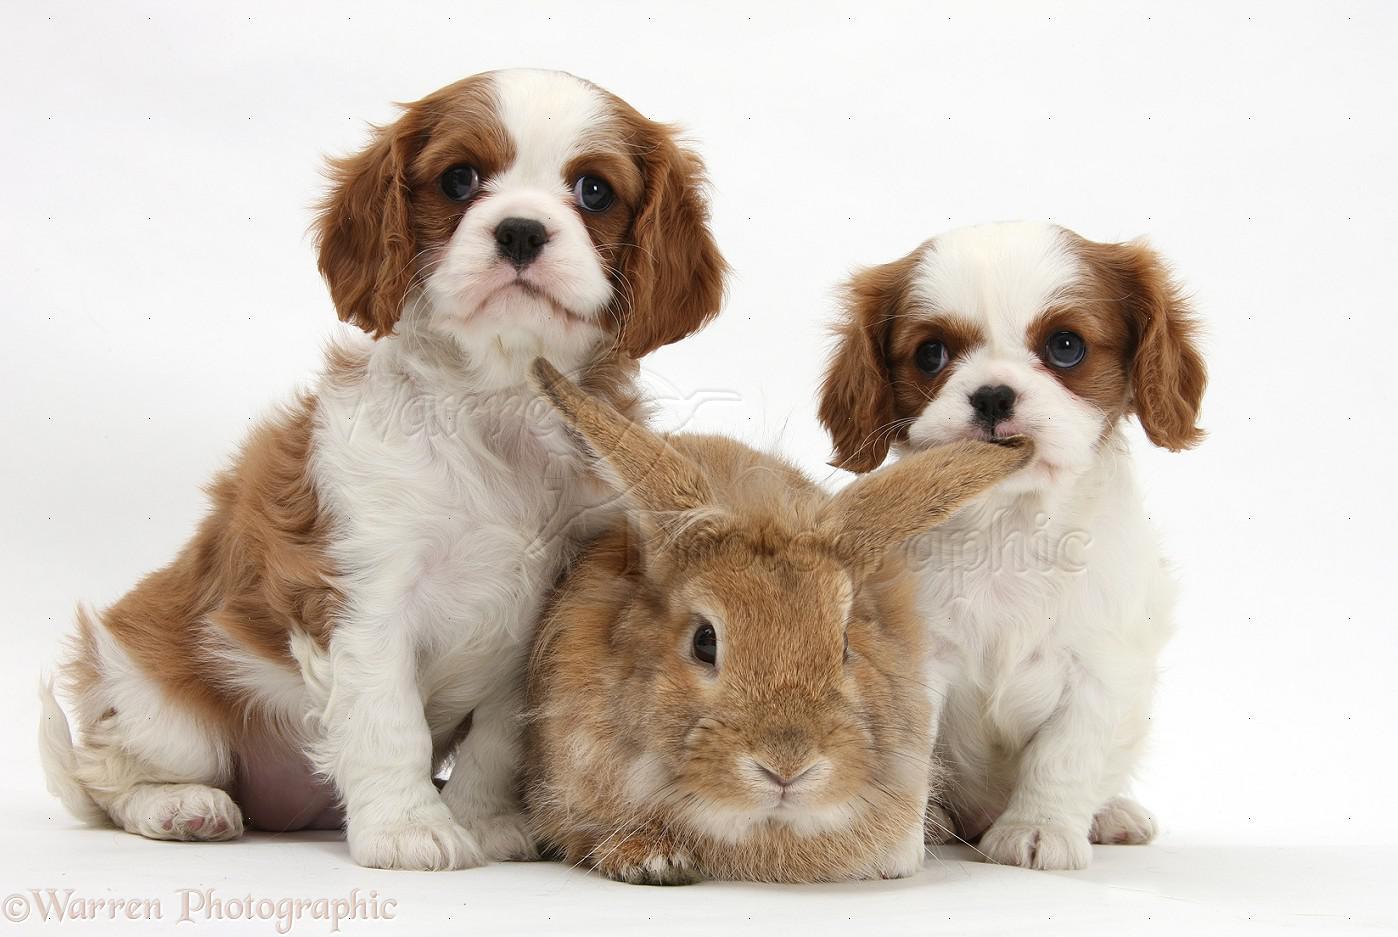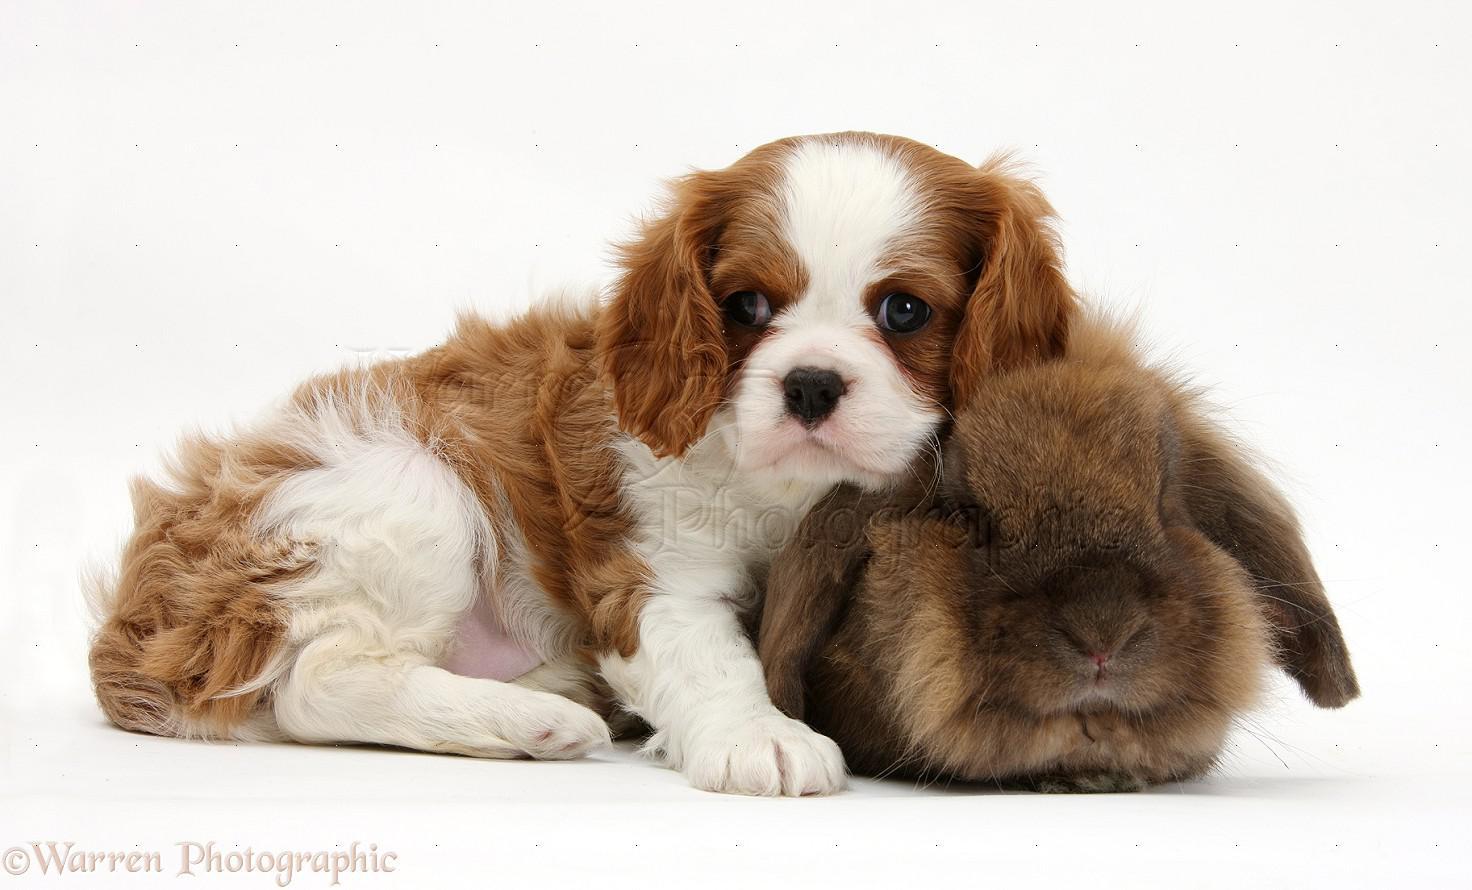The first image is the image on the left, the second image is the image on the right. Evaluate the accuracy of this statement regarding the images: "There are no more than three animals". Is it true? Answer yes or no. No. 